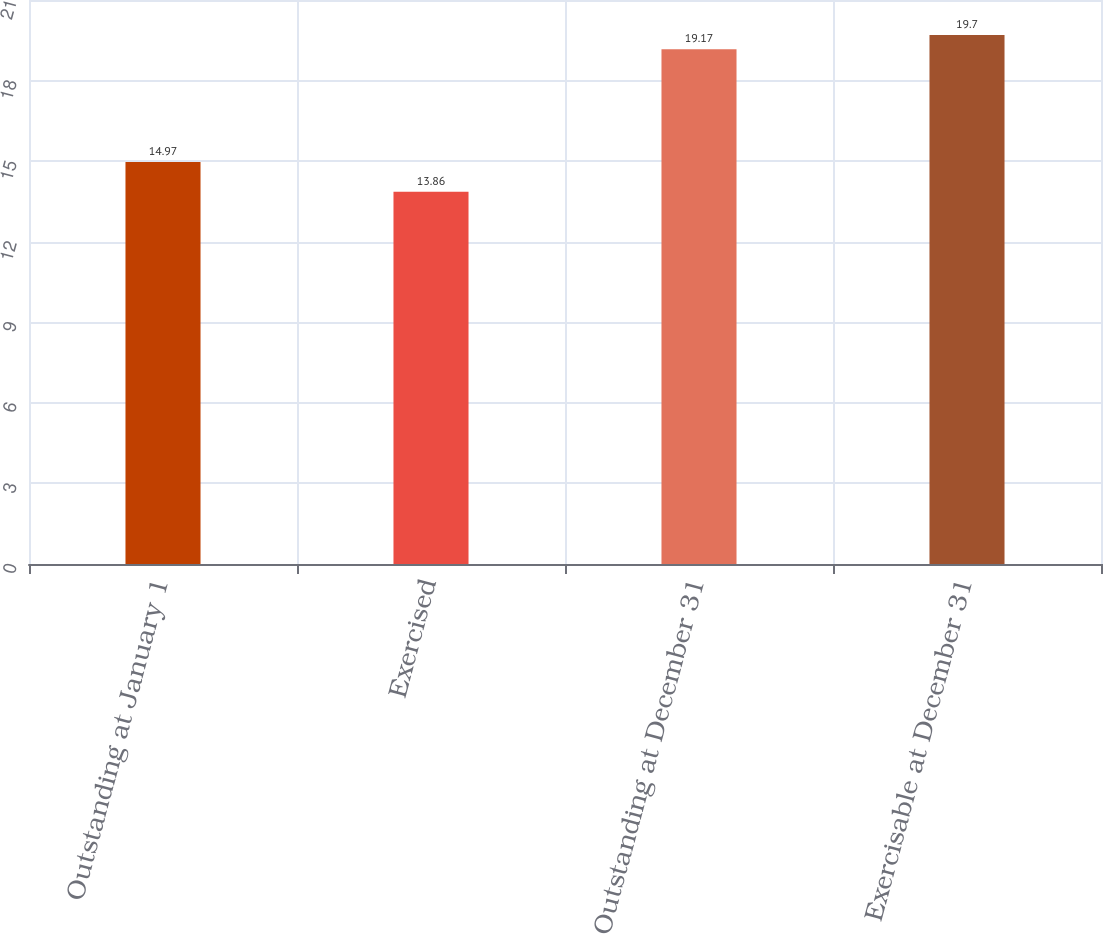<chart> <loc_0><loc_0><loc_500><loc_500><bar_chart><fcel>Outstanding at January 1<fcel>Exercised<fcel>Outstanding at December 31<fcel>Exercisable at December 31<nl><fcel>14.97<fcel>13.86<fcel>19.17<fcel>19.7<nl></chart> 